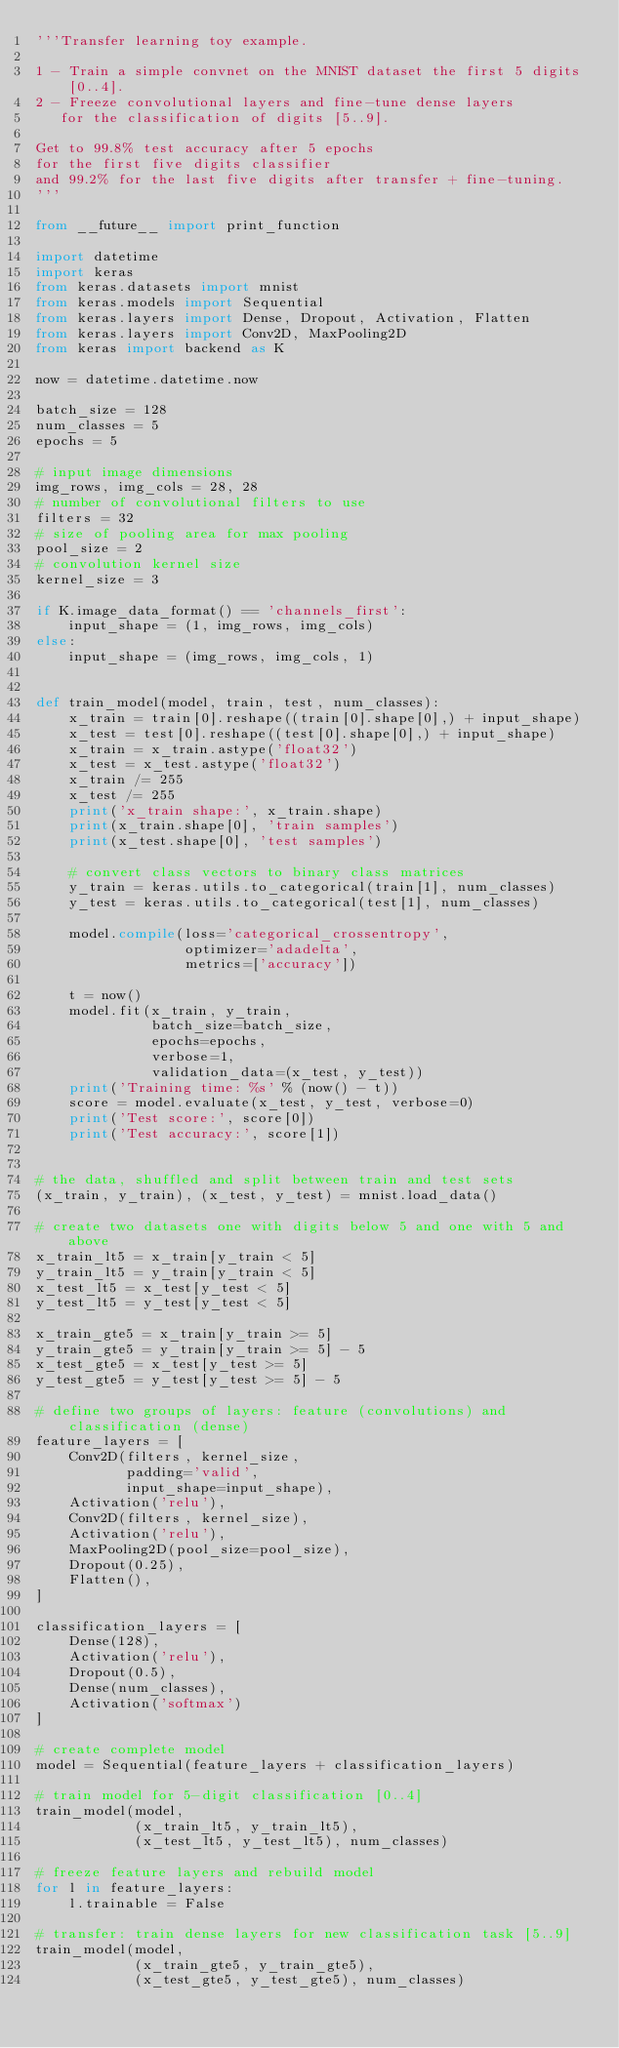<code> <loc_0><loc_0><loc_500><loc_500><_Python_>'''Transfer learning toy example.

1 - Train a simple convnet on the MNIST dataset the first 5 digits [0..4].
2 - Freeze convolutional layers and fine-tune dense layers
   for the classification of digits [5..9].

Get to 99.8% test accuracy after 5 epochs
for the first five digits classifier
and 99.2% for the last five digits after transfer + fine-tuning.
'''

from __future__ import print_function

import datetime
import keras
from keras.datasets import mnist
from keras.models import Sequential
from keras.layers import Dense, Dropout, Activation, Flatten
from keras.layers import Conv2D, MaxPooling2D
from keras import backend as K

now = datetime.datetime.now

batch_size = 128
num_classes = 5
epochs = 5

# input image dimensions
img_rows, img_cols = 28, 28
# number of convolutional filters to use
filters = 32
# size of pooling area for max pooling
pool_size = 2
# convolution kernel size
kernel_size = 3

if K.image_data_format() == 'channels_first':
    input_shape = (1, img_rows, img_cols)
else:
    input_shape = (img_rows, img_cols, 1)


def train_model(model, train, test, num_classes):
    x_train = train[0].reshape((train[0].shape[0],) + input_shape)
    x_test = test[0].reshape((test[0].shape[0],) + input_shape)
    x_train = x_train.astype('float32')
    x_test = x_test.astype('float32')
    x_train /= 255
    x_test /= 255
    print('x_train shape:', x_train.shape)
    print(x_train.shape[0], 'train samples')
    print(x_test.shape[0], 'test samples')

    # convert class vectors to binary class matrices
    y_train = keras.utils.to_categorical(train[1], num_classes)
    y_test = keras.utils.to_categorical(test[1], num_classes)

    model.compile(loss='categorical_crossentropy',
                  optimizer='adadelta',
                  metrics=['accuracy'])

    t = now()
    model.fit(x_train, y_train,
              batch_size=batch_size,
              epochs=epochs,
              verbose=1,
              validation_data=(x_test, y_test))
    print('Training time: %s' % (now() - t))
    score = model.evaluate(x_test, y_test, verbose=0)
    print('Test score:', score[0])
    print('Test accuracy:', score[1])


# the data, shuffled and split between train and test sets
(x_train, y_train), (x_test, y_test) = mnist.load_data()

# create two datasets one with digits below 5 and one with 5 and above
x_train_lt5 = x_train[y_train < 5]
y_train_lt5 = y_train[y_train < 5]
x_test_lt5 = x_test[y_test < 5]
y_test_lt5 = y_test[y_test < 5]

x_train_gte5 = x_train[y_train >= 5]
y_train_gte5 = y_train[y_train >= 5] - 5
x_test_gte5 = x_test[y_test >= 5]
y_test_gte5 = y_test[y_test >= 5] - 5

# define two groups of layers: feature (convolutions) and classification (dense)
feature_layers = [
    Conv2D(filters, kernel_size,
           padding='valid',
           input_shape=input_shape),
    Activation('relu'),
    Conv2D(filters, kernel_size),
    Activation('relu'),
    MaxPooling2D(pool_size=pool_size),
    Dropout(0.25),
    Flatten(),
]

classification_layers = [
    Dense(128),
    Activation('relu'),
    Dropout(0.5),
    Dense(num_classes),
    Activation('softmax')
]

# create complete model
model = Sequential(feature_layers + classification_layers)

# train model for 5-digit classification [0..4]
train_model(model,
            (x_train_lt5, y_train_lt5),
            (x_test_lt5, y_test_lt5), num_classes)

# freeze feature layers and rebuild model
for l in feature_layers:
    l.trainable = False

# transfer: train dense layers for new classification task [5..9]
train_model(model,
            (x_train_gte5, y_train_gte5),
            (x_test_gte5, y_test_gte5), num_classes)
</code> 